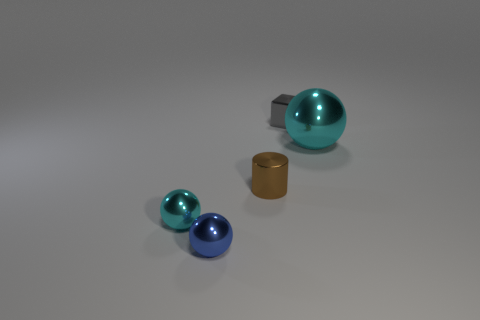Add 1 tiny matte cubes. How many objects exist? 6 Subtract all balls. How many objects are left? 2 Add 4 small shiny spheres. How many small shiny spheres exist? 6 Subtract 1 gray blocks. How many objects are left? 4 Subtract all purple things. Subtract all small spheres. How many objects are left? 3 Add 5 tiny gray things. How many tiny gray things are left? 6 